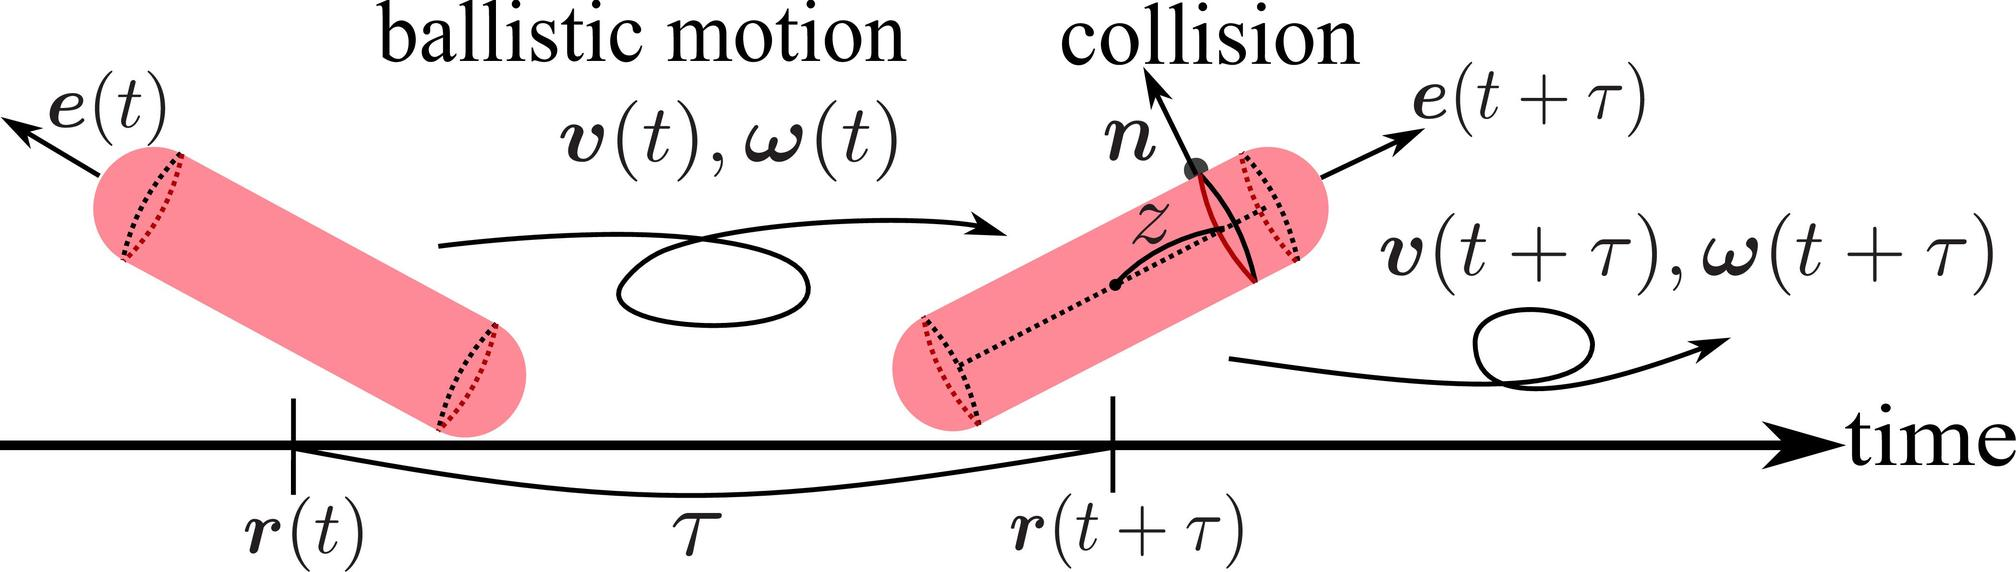Can you explain the significance of the vectors v(t) and (t) in the context of this image? Certainly! In the image, v(t) represents the linear velocity of the cylinder at time t, which illustrates how fast and in what direction the cylinder is moving right before the collision. Meanwhile, (t), or omega(t), symbolizes the angular velocity, indicating the rate of rotation of the cylinder about its axis at the same time. These vectors are fundamental in determining the kinetic energy and angular momentum of the cylinder, essential for understanding its motion dynamics. 